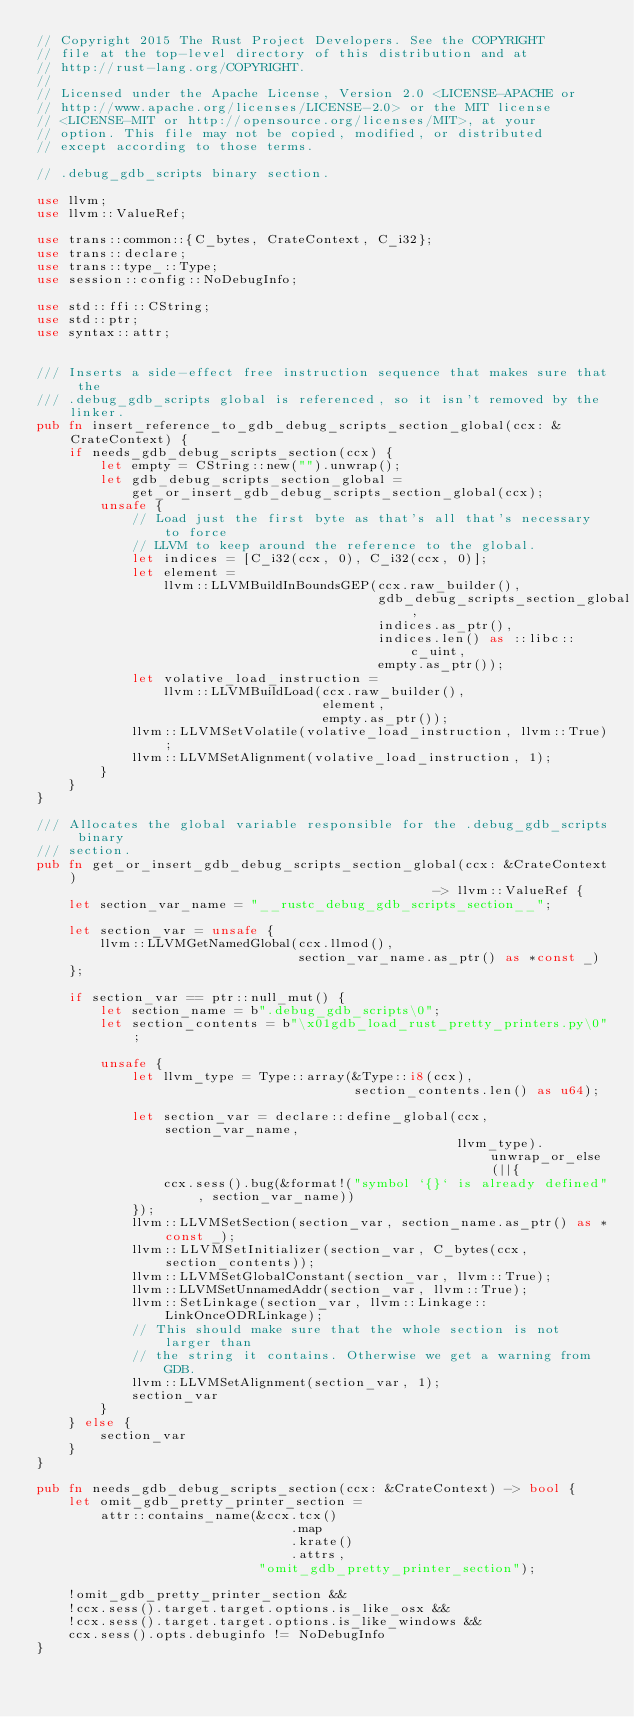Convert code to text. <code><loc_0><loc_0><loc_500><loc_500><_Rust_>// Copyright 2015 The Rust Project Developers. See the COPYRIGHT
// file at the top-level directory of this distribution and at
// http://rust-lang.org/COPYRIGHT.
//
// Licensed under the Apache License, Version 2.0 <LICENSE-APACHE or
// http://www.apache.org/licenses/LICENSE-2.0> or the MIT license
// <LICENSE-MIT or http://opensource.org/licenses/MIT>, at your
// option. This file may not be copied, modified, or distributed
// except according to those terms.

// .debug_gdb_scripts binary section.

use llvm;
use llvm::ValueRef;

use trans::common::{C_bytes, CrateContext, C_i32};
use trans::declare;
use trans::type_::Type;
use session::config::NoDebugInfo;

use std::ffi::CString;
use std::ptr;
use syntax::attr;


/// Inserts a side-effect free instruction sequence that makes sure that the
/// .debug_gdb_scripts global is referenced, so it isn't removed by the linker.
pub fn insert_reference_to_gdb_debug_scripts_section_global(ccx: &CrateContext) {
    if needs_gdb_debug_scripts_section(ccx) {
        let empty = CString::new("").unwrap();
        let gdb_debug_scripts_section_global =
            get_or_insert_gdb_debug_scripts_section_global(ccx);
        unsafe {
            // Load just the first byte as that's all that's necessary to force
            // LLVM to keep around the reference to the global.
            let indices = [C_i32(ccx, 0), C_i32(ccx, 0)];
            let element =
                llvm::LLVMBuildInBoundsGEP(ccx.raw_builder(),
                                           gdb_debug_scripts_section_global,
                                           indices.as_ptr(),
                                           indices.len() as ::libc::c_uint,
                                           empty.as_ptr());
            let volative_load_instruction =
                llvm::LLVMBuildLoad(ccx.raw_builder(),
                                    element,
                                    empty.as_ptr());
            llvm::LLVMSetVolatile(volative_load_instruction, llvm::True);
            llvm::LLVMSetAlignment(volative_load_instruction, 1);
        }
    }
}

/// Allocates the global variable responsible for the .debug_gdb_scripts binary
/// section.
pub fn get_or_insert_gdb_debug_scripts_section_global(ccx: &CrateContext)
                                                  -> llvm::ValueRef {
    let section_var_name = "__rustc_debug_gdb_scripts_section__";

    let section_var = unsafe {
        llvm::LLVMGetNamedGlobal(ccx.llmod(),
                                 section_var_name.as_ptr() as *const _)
    };

    if section_var == ptr::null_mut() {
        let section_name = b".debug_gdb_scripts\0";
        let section_contents = b"\x01gdb_load_rust_pretty_printers.py\0";

        unsafe {
            let llvm_type = Type::array(&Type::i8(ccx),
                                        section_contents.len() as u64);

            let section_var = declare::define_global(ccx, section_var_name,
                                                     llvm_type).unwrap_or_else(||{
                ccx.sess().bug(&format!("symbol `{}` is already defined", section_var_name))
            });
            llvm::LLVMSetSection(section_var, section_name.as_ptr() as *const _);
            llvm::LLVMSetInitializer(section_var, C_bytes(ccx, section_contents));
            llvm::LLVMSetGlobalConstant(section_var, llvm::True);
            llvm::LLVMSetUnnamedAddr(section_var, llvm::True);
            llvm::SetLinkage(section_var, llvm::Linkage::LinkOnceODRLinkage);
            // This should make sure that the whole section is not larger than
            // the string it contains. Otherwise we get a warning from GDB.
            llvm::LLVMSetAlignment(section_var, 1);
            section_var
        }
    } else {
        section_var
    }
}

pub fn needs_gdb_debug_scripts_section(ccx: &CrateContext) -> bool {
    let omit_gdb_pretty_printer_section =
        attr::contains_name(&ccx.tcx()
                                .map
                                .krate()
                                .attrs,
                            "omit_gdb_pretty_printer_section");

    !omit_gdb_pretty_printer_section &&
    !ccx.sess().target.target.options.is_like_osx &&
    !ccx.sess().target.target.options.is_like_windows &&
    ccx.sess().opts.debuginfo != NoDebugInfo
}
</code> 